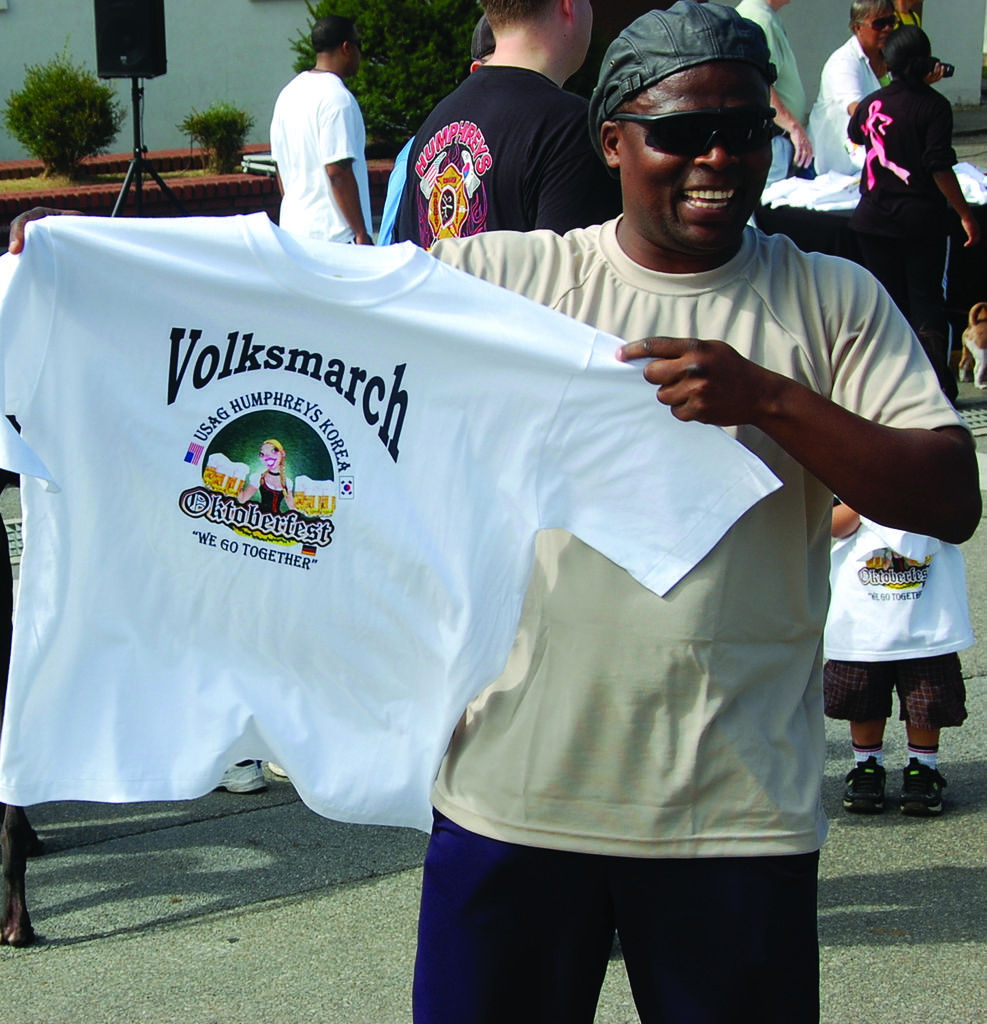What event is the shirt for?
Ensure brevity in your answer.  Volksmarch. 